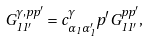<formula> <loc_0><loc_0><loc_500><loc_500>G ^ { \gamma , p p ^ { \prime } } _ { 1 1 ^ { \prime } } = c ^ { \gamma } _ { \alpha _ { 1 } \alpha _ { 1 } ^ { \prime } } p ^ { \prime } G ^ { p p ^ { \prime } } _ { 1 1 ^ { \prime } } ,</formula> 